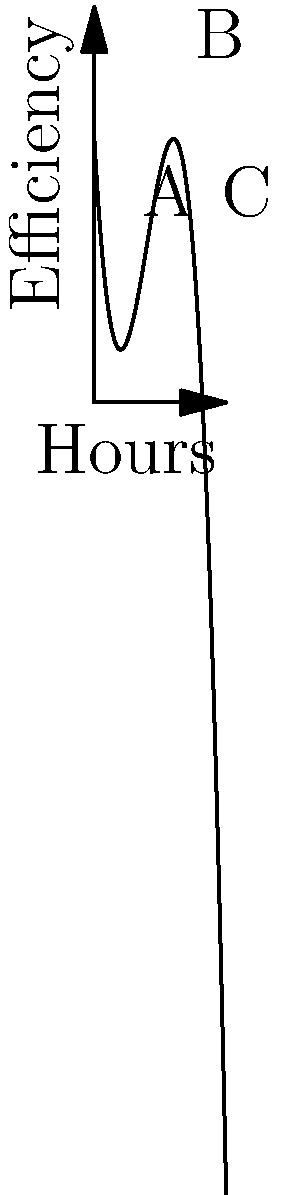The efficiency of the royal's daily schedule can be modeled by the cubic function $f(x) = -0.5x^3 + 6x^2 - 18x + 20$, where $x$ represents the number of hours spent on activities and $f(x)$ represents the efficiency score. Using the graph, determine the optimal number of hours the royal should spend on activities to maximize efficiency, and calculate the maximum efficiency score. To solve this problem, we'll follow these steps:

1) The optimal number of hours (x-value) occurs at the peak of the curve, which is point B on the graph.

2) To find the x-coordinate of point B, we can estimate from the graph. It appears to be at x = 6 hours.

3) To verify this and find the exact maximum efficiency score, we can use calculus:
   
   a) Find the derivative: $f'(x) = -1.5x^2 + 12x - 18$
   
   b) Set $f'(x) = 0$ and solve:
      $-1.5x^2 + 12x - 18 = 0$
      $-3x^2 + 24x - 36 = 0$
      $-3(x^2 - 8x + 12) = 0$
      $-3(x - 6)(x - 2) = 0$
      $x = 6$ or $x = 2$

   c) The second derivative $f''(x) = -3x + 12$ is negative when $x = 6$, confirming it's a maximum.

4) Calculate the maximum efficiency score:
   $f(6) = -0.5(6)^3 + 6(6)^2 - 18(6) + 20$
         $= -108 + 216 - 108 + 20$
         $= 20$

Therefore, the optimal number of hours is 6, and the maximum efficiency score is 28.
Answer: 6 hours; 28 efficiency score 